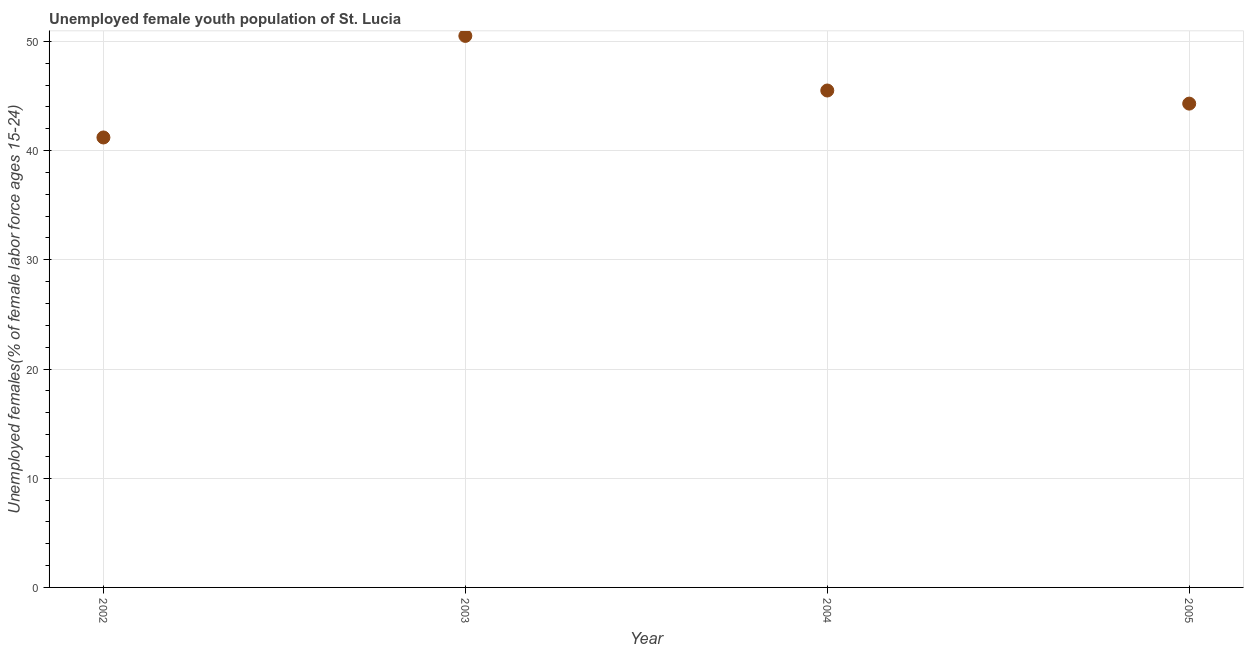What is the unemployed female youth in 2002?
Provide a succinct answer. 41.2. Across all years, what is the maximum unemployed female youth?
Give a very brief answer. 50.5. Across all years, what is the minimum unemployed female youth?
Offer a terse response. 41.2. What is the sum of the unemployed female youth?
Your answer should be very brief. 181.5. What is the difference between the unemployed female youth in 2004 and 2005?
Offer a very short reply. 1.2. What is the average unemployed female youth per year?
Provide a short and direct response. 45.38. What is the median unemployed female youth?
Provide a short and direct response. 44.9. What is the ratio of the unemployed female youth in 2004 to that in 2005?
Your answer should be compact. 1.03. Is the difference between the unemployed female youth in 2002 and 2005 greater than the difference between any two years?
Your response must be concise. No. Is the sum of the unemployed female youth in 2003 and 2004 greater than the maximum unemployed female youth across all years?
Offer a terse response. Yes. What is the difference between the highest and the lowest unemployed female youth?
Your answer should be compact. 9.3. Does the unemployed female youth monotonically increase over the years?
Provide a short and direct response. No. Does the graph contain any zero values?
Your answer should be very brief. No. What is the title of the graph?
Make the answer very short. Unemployed female youth population of St. Lucia. What is the label or title of the Y-axis?
Provide a succinct answer. Unemployed females(% of female labor force ages 15-24). What is the Unemployed females(% of female labor force ages 15-24) in 2002?
Offer a very short reply. 41.2. What is the Unemployed females(% of female labor force ages 15-24) in 2003?
Offer a very short reply. 50.5. What is the Unemployed females(% of female labor force ages 15-24) in 2004?
Ensure brevity in your answer.  45.5. What is the Unemployed females(% of female labor force ages 15-24) in 2005?
Offer a very short reply. 44.3. What is the difference between the Unemployed females(% of female labor force ages 15-24) in 2002 and 2003?
Your response must be concise. -9.3. What is the difference between the Unemployed females(% of female labor force ages 15-24) in 2002 and 2004?
Your answer should be very brief. -4.3. What is the ratio of the Unemployed females(% of female labor force ages 15-24) in 2002 to that in 2003?
Give a very brief answer. 0.82. What is the ratio of the Unemployed females(% of female labor force ages 15-24) in 2002 to that in 2004?
Your answer should be very brief. 0.91. What is the ratio of the Unemployed females(% of female labor force ages 15-24) in 2003 to that in 2004?
Ensure brevity in your answer.  1.11. What is the ratio of the Unemployed females(% of female labor force ages 15-24) in 2003 to that in 2005?
Your response must be concise. 1.14. 